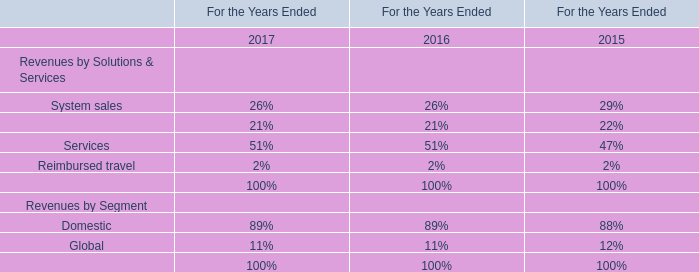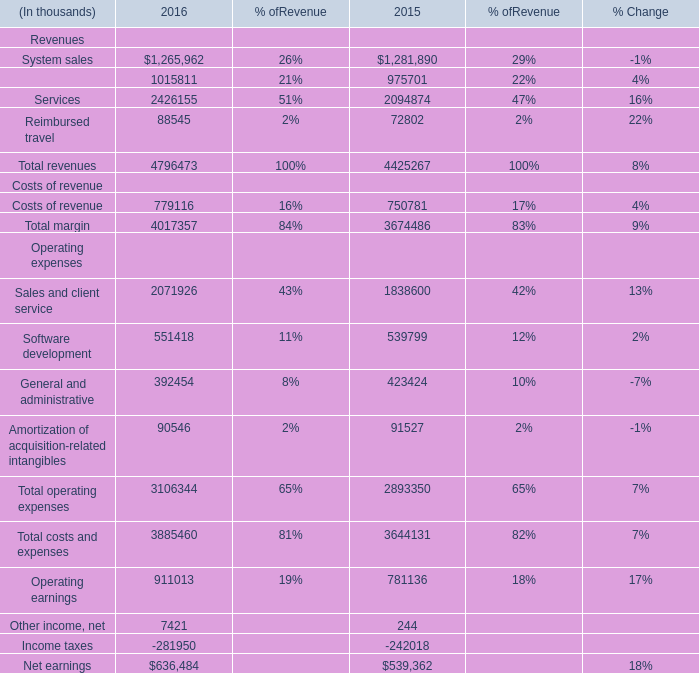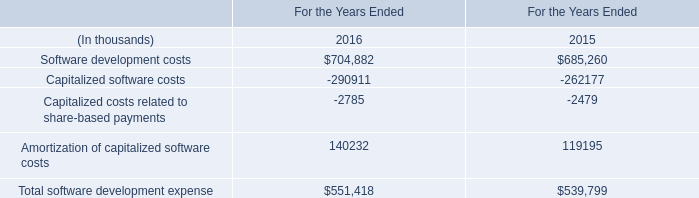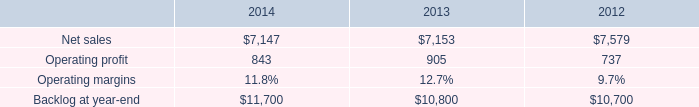What is the sum of Software development costs of For the Years Ended 2015, and Net earnings Operating expenses of 2015 ? 
Computations: (685260.0 + 539362.0)
Answer: 1224622.0. 